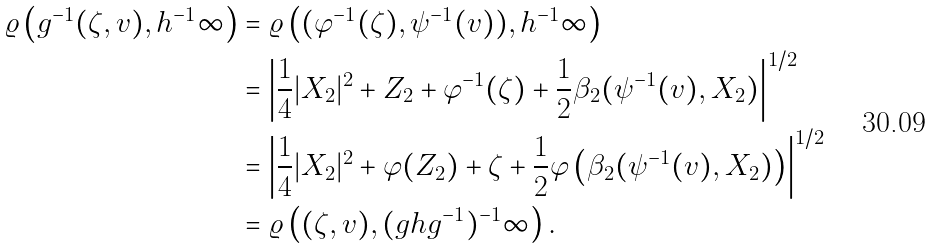Convert formula to latex. <formula><loc_0><loc_0><loc_500><loc_500>\varrho \left ( g ^ { - 1 } ( \zeta , v ) , h ^ { - 1 } \infty \right ) & = \varrho \left ( ( \varphi ^ { - 1 } ( \zeta ) , \psi ^ { - 1 } ( v ) ) , h ^ { - 1 } \infty \right ) \\ & = \left | \frac { 1 } { 4 } | X _ { 2 } | ^ { 2 } + Z _ { 2 } + \varphi ^ { - 1 } ( \zeta ) + \frac { 1 } { 2 } \beta _ { 2 } ( \psi ^ { - 1 } ( v ) , X _ { 2 } ) \right | ^ { 1 / 2 } \\ & = \left | \frac { 1 } { 4 } | X _ { 2 } | ^ { 2 } + \varphi ( Z _ { 2 } ) + \zeta + \frac { 1 } { 2 } \varphi \left ( \beta _ { 2 } ( \psi ^ { - 1 } ( v ) , X _ { 2 } ) \right ) \right | ^ { 1 / 2 } \\ & = \varrho \left ( ( \zeta , v ) , ( g h g ^ { - 1 } ) ^ { - 1 } \infty \right ) .</formula> 